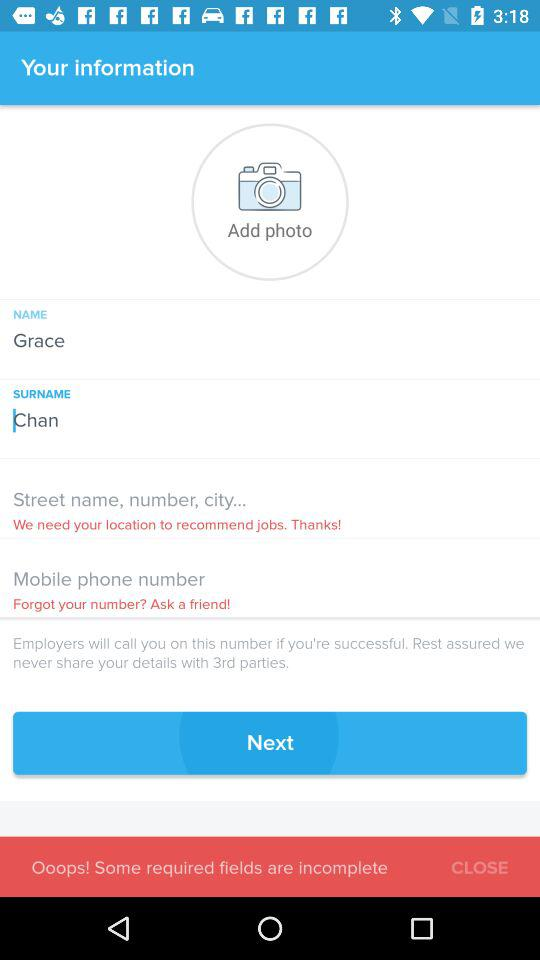What is the name? The name is Grace. 